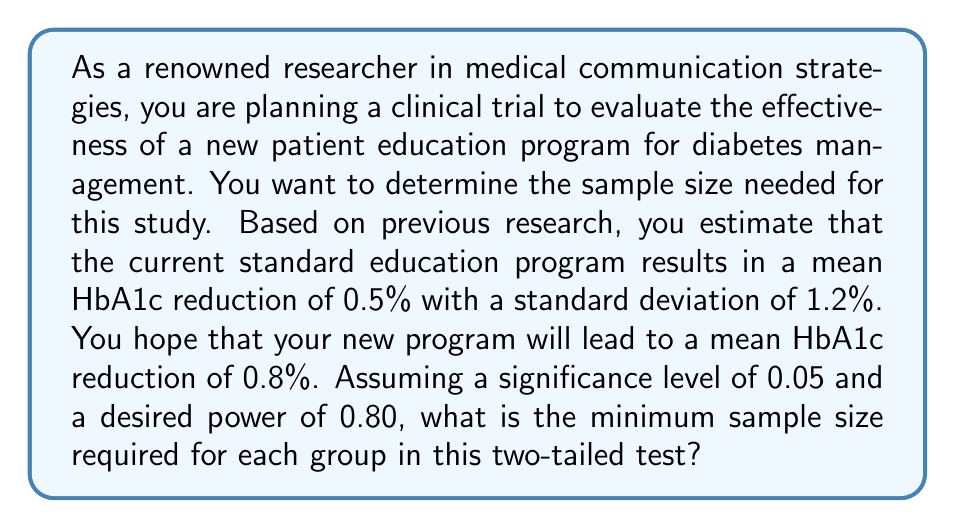Solve this math problem. To determine the sample size for this clinical trial, we'll use the formula for sample size calculation in a two-sample t-test:

$$ n = \frac{2(Z_{\alpha/2} + Z_{\beta})^2 \sigma^2}{\Delta^2} $$

Where:
- $n$ is the sample size per group
- $Z_{\alpha/2}$ is the critical value of the normal distribution at $\alpha/2$
- $Z_{\beta}$ is the critical value of the normal distribution at $\beta$
- $\sigma$ is the standard deviation
- $\Delta$ is the difference in means we want to detect

Given:
- Significance level $\alpha = 0.05$ (two-tailed)
- Desired power = 0.80, so $\beta = 1 - 0.80 = 0.20$
- Standard deviation $\sigma = 1.2$
- Difference in means $\Delta = 0.8 - 0.5 = 0.3$

Step 1: Determine $Z_{\alpha/2}$ and $Z_{\beta}$
$Z_{\alpha/2} = Z_{0.025} = 1.96$ (from standard normal table)
$Z_{\beta} = Z_{0.20} = 0.84$ (from standard normal table)

Step 2: Plug values into the formula
$$ n = \frac{2(1.96 + 0.84)^2 (1.2)^2}{(0.3)^2} $$

Step 3: Calculate
$$ n = \frac{2(2.80)^2 (1.44)}{0.09} = \frac{22.4 \times 1.44}{0.09} = 358.4 $$

Step 4: Round up to the nearest whole number
$n = 359$

Therefore, the minimum sample size required for each group is 359 participants.
Answer: 359 participants per group 